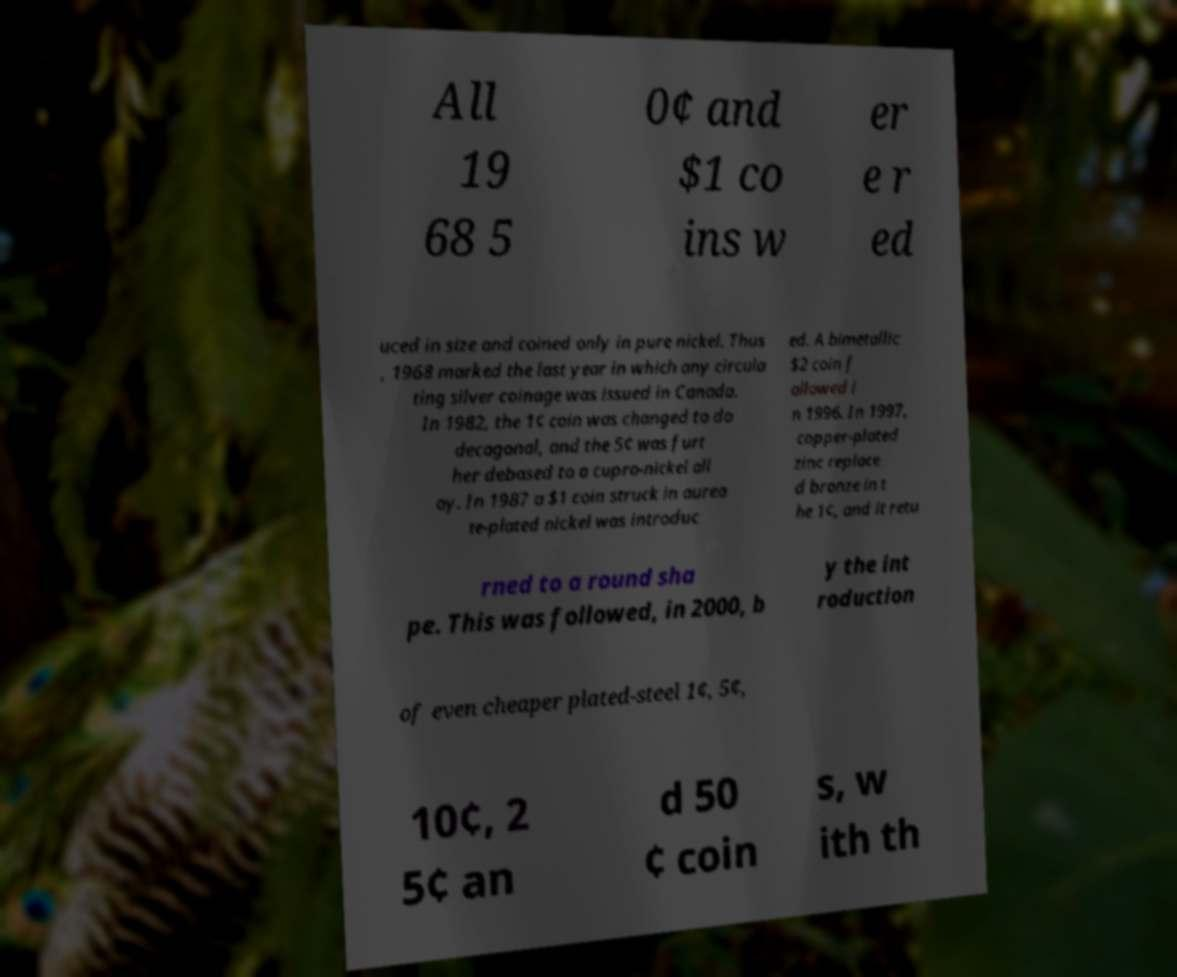Please read and relay the text visible in this image. What does it say? All 19 68 5 0¢ and $1 co ins w er e r ed uced in size and coined only in pure nickel. Thus , 1968 marked the last year in which any circula ting silver coinage was issued in Canada. In 1982, the 1¢ coin was changed to do decagonal, and the 5¢ was furt her debased to a cupro-nickel all oy. In 1987 a $1 coin struck in aurea te-plated nickel was introduc ed. A bimetallic $2 coin f ollowed i n 1996. In 1997, copper-plated zinc replace d bronze in t he 1¢, and it retu rned to a round sha pe. This was followed, in 2000, b y the int roduction of even cheaper plated-steel 1¢, 5¢, 10¢, 2 5¢ an d 50 ¢ coin s, w ith th 